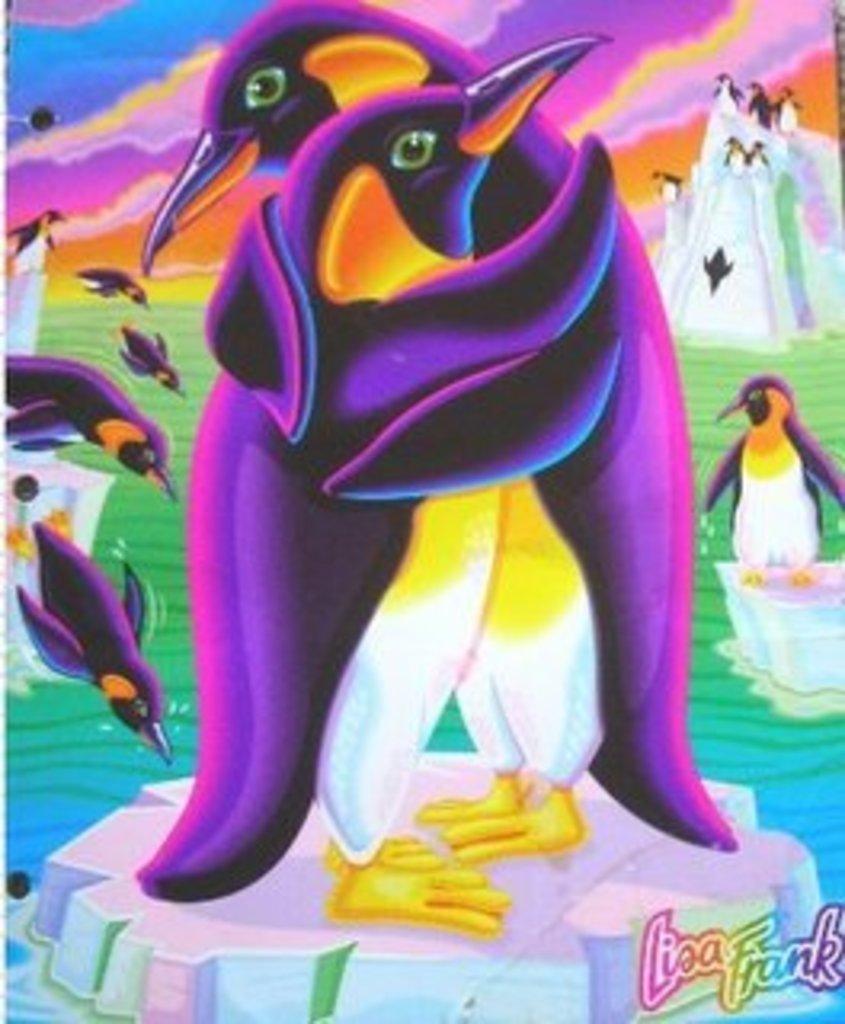Can you describe this image briefly? This is an animated image. We can see some penguins in that image. 